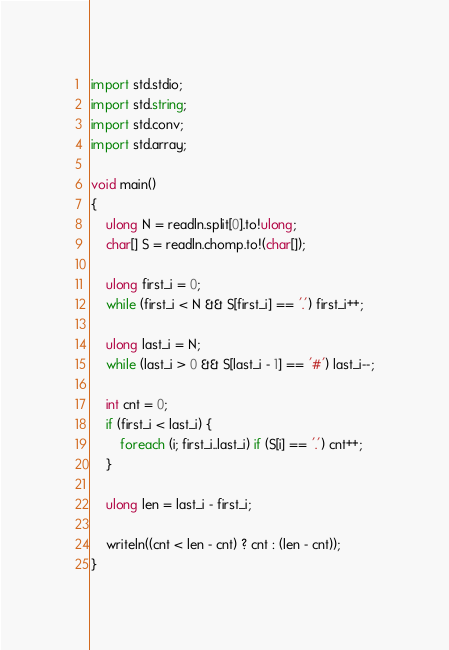Convert code to text. <code><loc_0><loc_0><loc_500><loc_500><_D_>import std.stdio;
import std.string;
import std.conv;
import std.array;

void main()
{
    ulong N = readln.split[0].to!ulong;
    char[] S = readln.chomp.to!(char[]);

    ulong first_i = 0;
    while (first_i < N && S[first_i] == '.') first_i++;

    ulong last_i = N;
    while (last_i > 0 && S[last_i - 1] == '#') last_i--;

    int cnt = 0;
    if (first_i < last_i) {
        foreach (i; first_i..last_i) if (S[i] == '.') cnt++;
    }

    ulong len = last_i - first_i;

    writeln((cnt < len - cnt) ? cnt : (len - cnt));
}

</code> 